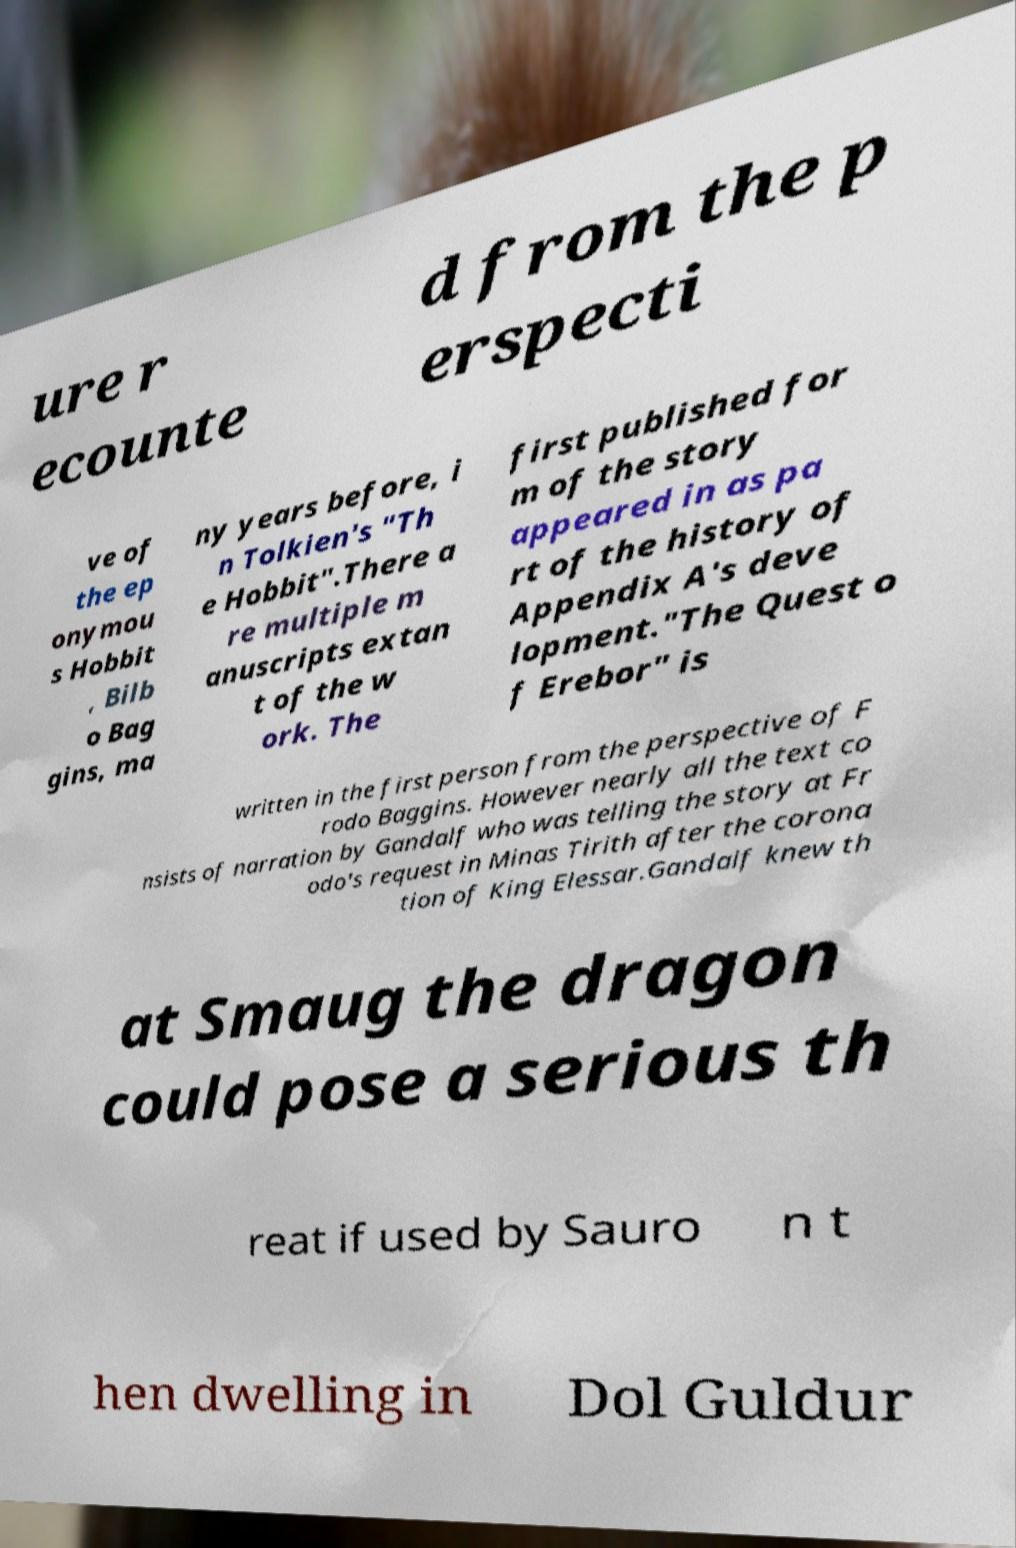For documentation purposes, I need the text within this image transcribed. Could you provide that? ure r ecounte d from the p erspecti ve of the ep onymou s Hobbit , Bilb o Bag gins, ma ny years before, i n Tolkien's "Th e Hobbit".There a re multiple m anuscripts extan t of the w ork. The first published for m of the story appeared in as pa rt of the history of Appendix A's deve lopment."The Quest o f Erebor" is written in the first person from the perspective of F rodo Baggins. However nearly all the text co nsists of narration by Gandalf who was telling the story at Fr odo's request in Minas Tirith after the corona tion of King Elessar.Gandalf knew th at Smaug the dragon could pose a serious th reat if used by Sauro n t hen dwelling in Dol Guldur 